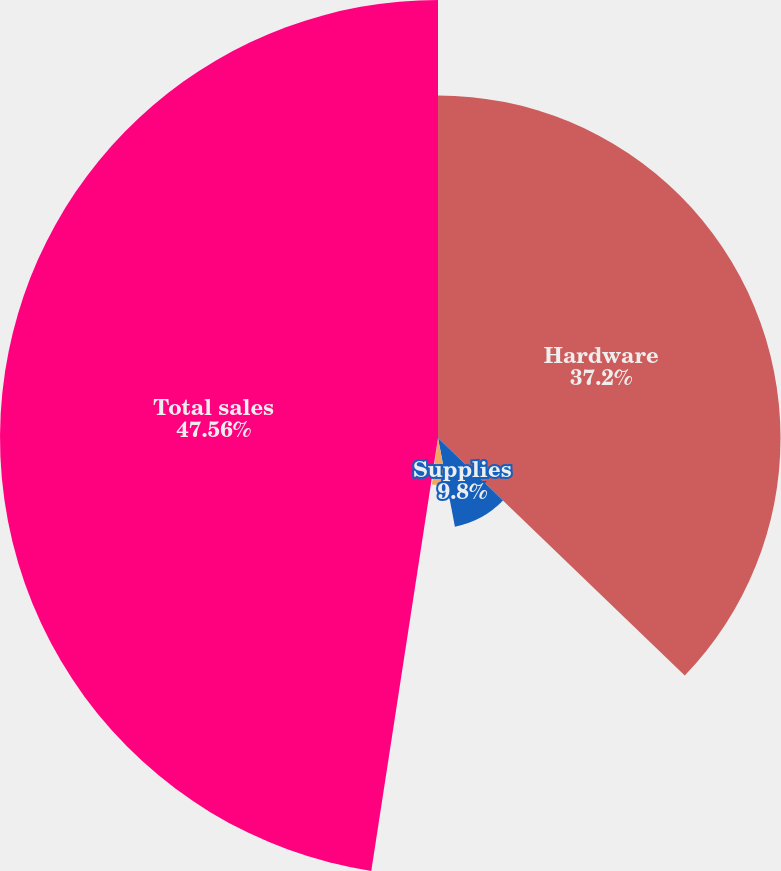Convert chart to OTSL. <chart><loc_0><loc_0><loc_500><loc_500><pie_chart><fcel>Hardware<fcel>Supplies<fcel>Service and software<fcel>Shipping and handling<fcel>Total sales<nl><fcel>37.2%<fcel>9.8%<fcel>5.08%<fcel>0.36%<fcel>47.57%<nl></chart> 